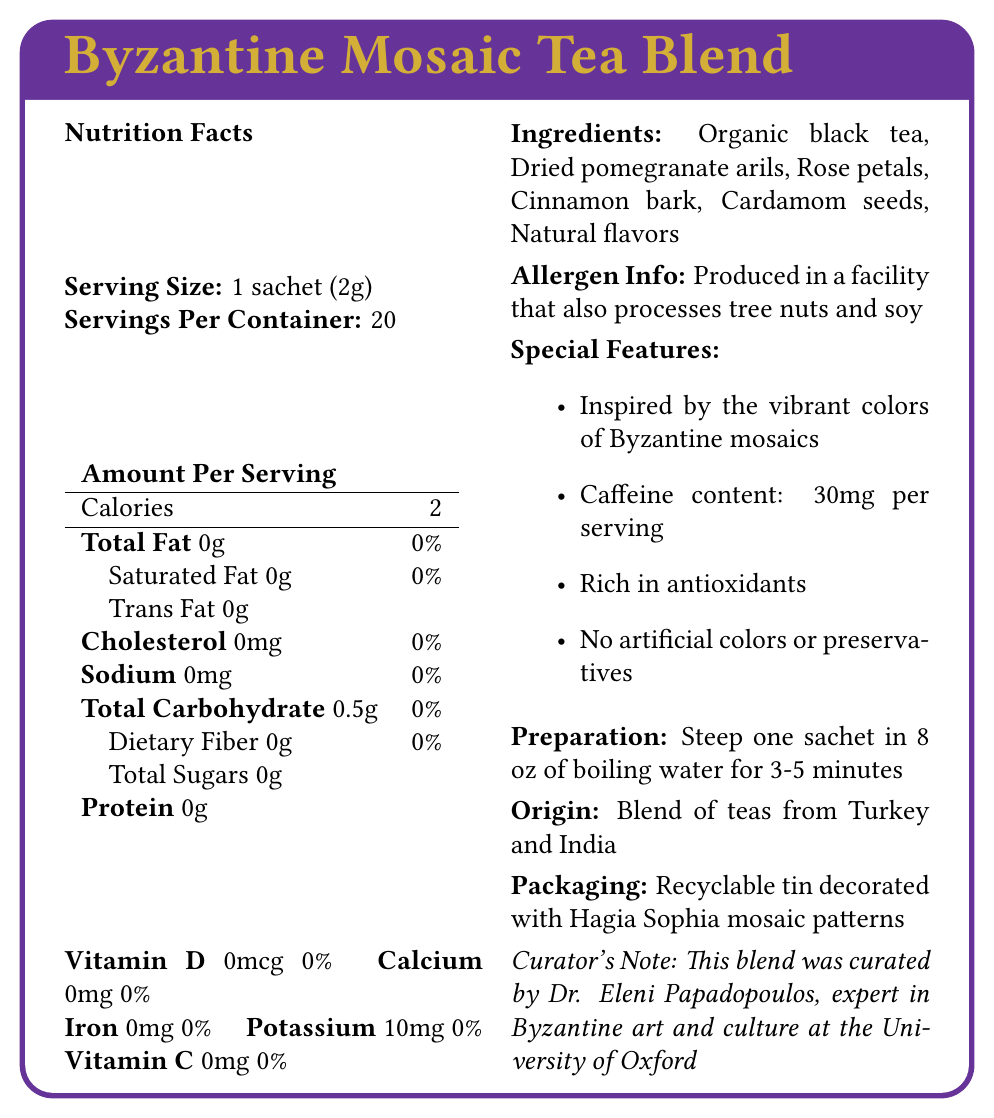what is the serving size for the Byzantine Mosaic Tea Blend? The document clearly states that the serving size is 1 sachet (2g).
Answer: 1 sachet (2g) how many calories are there per serving? The document lists the amount of calories per serving as 2.
Answer: 2 what ingredients are included in this tea blend? The "Ingredients" section of the document lists all the ingredients included in the tea blend.
Answer: Organic black tea, Dried pomegranate arils, Rose petals, Cinnamon bark, Cardamom seeds, Natural flavors what is the amount of potassium per serving? The document specifies that each serving contains 10mg of potassium.
Answer: 10mg are there any artificial colors or preservatives in the tea? The document mentions under "Special Features" that the tea has no artificial colors or preservatives.
Answer: No which vitamin is absent in the tea? A. Vitamin A B. Vitamin B12 C. Vitamin D D. Vitamin C The document states that Vitamin D is not present, as it shows '0 mcg 0%' for Vitamin D.
Answer: C. Vitamin D how much caffeine content is there per serving? A. 20mg B. 25mg C. 30mg D. 35mg The document under "Special Features" mentions that the caffeine content is 30mg per serving.
Answer: C. 30mg which feature is inspired by Byzantine mosaics? A. Color B. Flavor C. Packaging D. Origin The document mentions that the recyclable tin is decorated with Hagia Sophia mosaic patterns, which are inspired by Byzantine mosaics.
Answer: C. Packaging is this tea produced in a facility that processes tree nuts and soy? The document includes an "Allergen Info" section, which states that the product is produced in a facility that also processes tree nuts and soy.
Answer: Yes can the exact antioxidant count in the tea be determined from this document? The document mentions that the tea is "rich in antioxidants" but does not provide an exact count.
Answer: Cannot be determined where are the teas in this blend sourced from? The "Origin" section of the document notes that the tea blend is a mix of teas from Turkey and India.
Answer: Turkey and India what is the suggested preparation method for this tea? The "Preparation" section provides instructions on how to prepare the tea.
Answer: Steep one sachet in 8 oz of boiling water for 3-5 minutes who curated this tea blend? The document includes a "Curator's Note" stating that the blend was curated by Dr. Eleni Papadopoulos.
Answer: Dr. Eleni Papadopoulos summarize the main features and contents of the Byzantine Mosaic Tea Blend The document outlines the nutritional information, ingredients, special features, packaging, origin, and curatorial expertise of the tea blend.
Answer: The Byzantine Mosaic Tea Blend is a specialty tea inspired by Byzantine mosaics. It has a serving size of 1 sachet (2g) with 20 servings per container. It contains 2 calories per serving and has ingredients such as organic black tea, dried pomegranate arils, rose petals, cinnamon bark, cardamom seeds, and natural flavors. It has no artificial colors or preservatives and contains 30mg of caffeine per serving. It is rich in antioxidants and packaged in a recyclable tin with Hagia Sophia mosaic patterns. The blend was curated by Dr. Eleni Papadopoulos, an expert in Byzantine art and culture. 